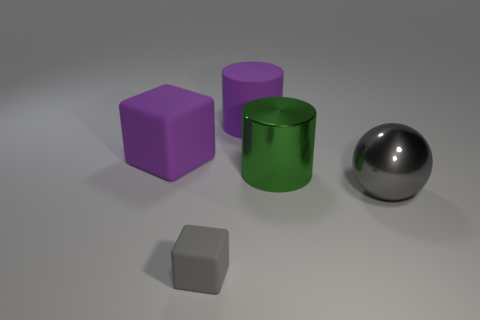Is there any other thing that has the same size as the gray matte block?
Give a very brief answer. No. What material is the purple object that is the same shape as the tiny gray matte thing?
Provide a short and direct response. Rubber. The tiny thing is what shape?
Provide a succinct answer. Cube. There is a object that is in front of the big green metallic object and on the left side of the green shiny cylinder; what material is it made of?
Your answer should be very brief. Rubber. What shape is the gray thing that is made of the same material as the large green thing?
Make the answer very short. Sphere. What is the size of the cylinder that is the same material as the sphere?
Keep it short and to the point. Large. The object that is both in front of the green metal thing and behind the small gray object has what shape?
Offer a terse response. Sphere. What is the size of the cylinder that is to the right of the big cylinder that is behind the big cube?
Provide a short and direct response. Large. How many other things are the same color as the big metal ball?
Your answer should be compact. 1. What material is the small gray thing?
Your answer should be very brief. Rubber. 